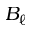Convert formula to latex. <formula><loc_0><loc_0><loc_500><loc_500>B _ { \ell }</formula> 